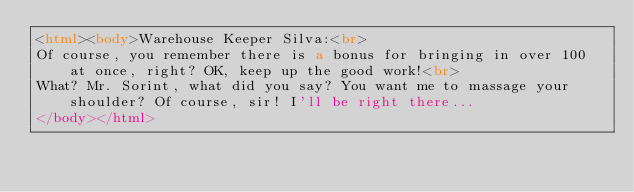<code> <loc_0><loc_0><loc_500><loc_500><_HTML_><html><body>Warehouse Keeper Silva:<br>
Of course, you remember there is a bonus for bringing in over 100 at once, right? OK, keep up the good work!<br>
What? Mr. Sorint, what did you say? You want me to massage your shoulder? Of course, sir! I'll be right there...
</body></html></code> 